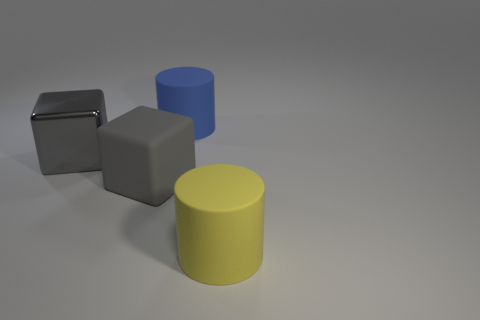Add 2 big rubber cylinders. How many objects exist? 6 Subtract 0 cyan spheres. How many objects are left? 4 Subtract all metal objects. Subtract all small cyan metallic cylinders. How many objects are left? 3 Add 2 large rubber blocks. How many large rubber blocks are left? 3 Add 1 large rubber cylinders. How many large rubber cylinders exist? 3 